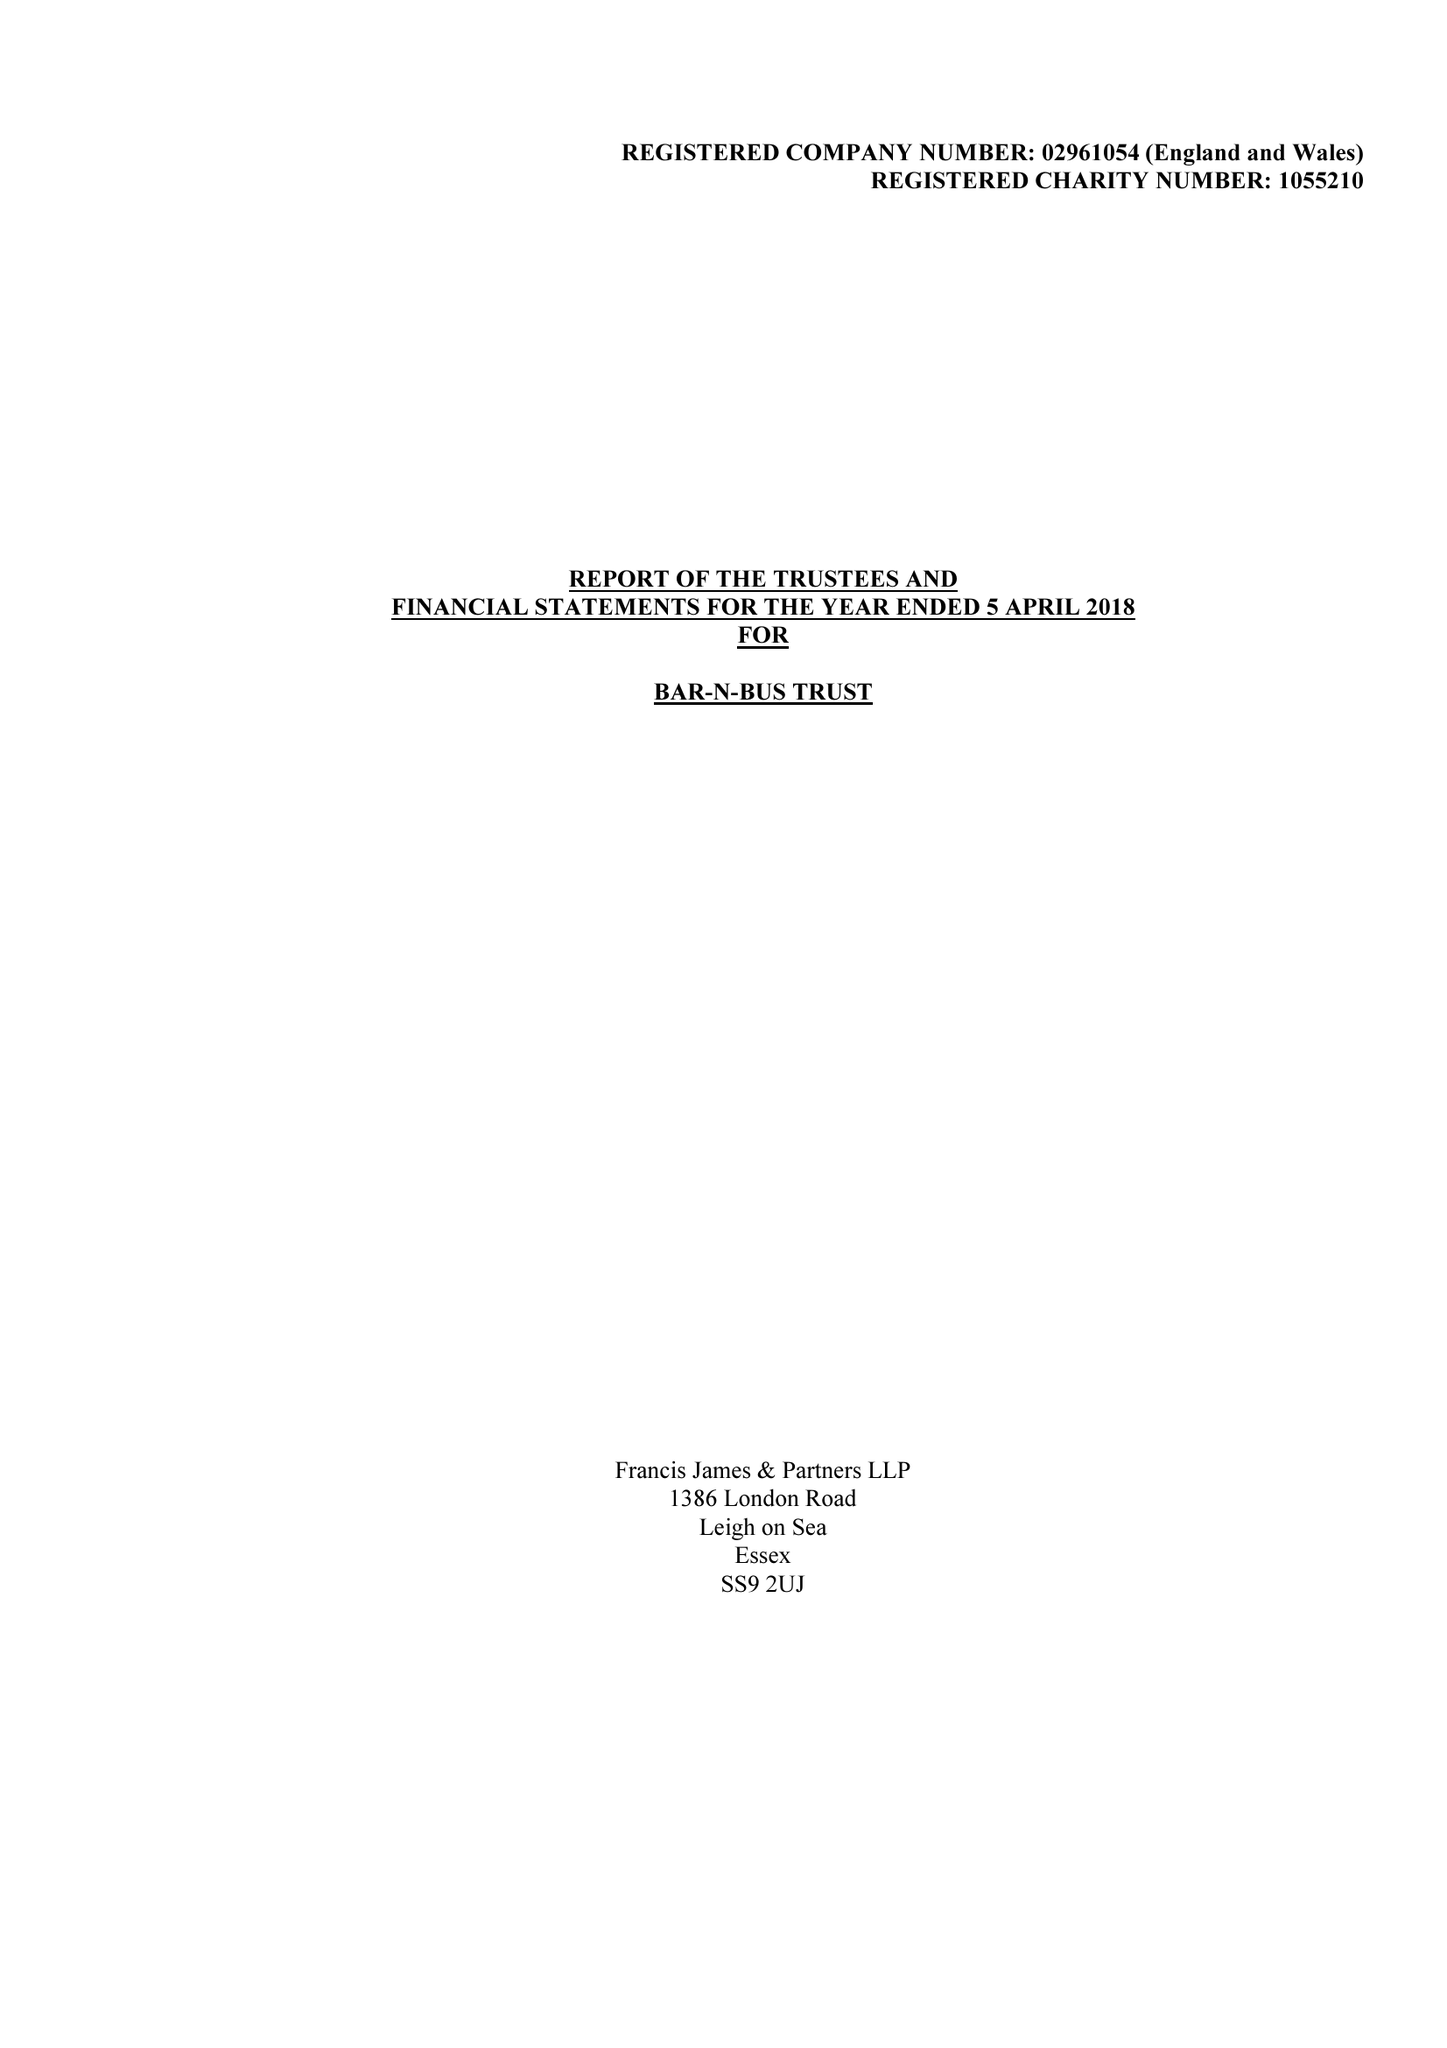What is the value for the income_annually_in_british_pounds?
Answer the question using a single word or phrase. 41927.00 